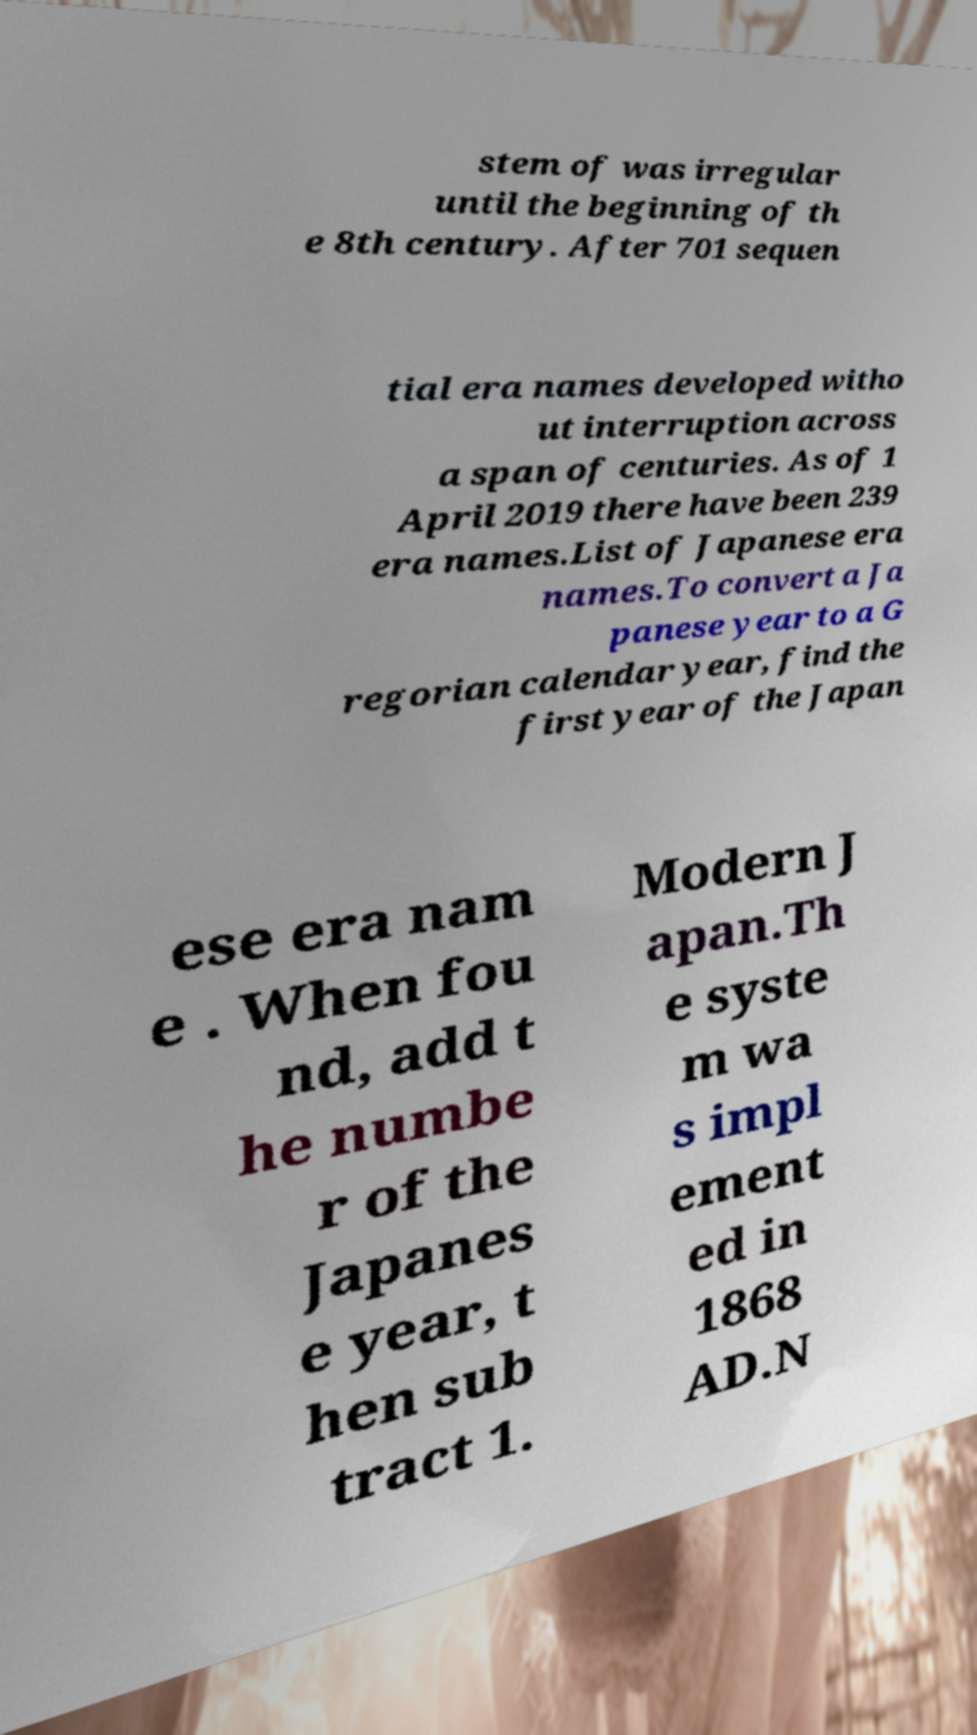I need the written content from this picture converted into text. Can you do that? stem of was irregular until the beginning of th e 8th century. After 701 sequen tial era names developed witho ut interruption across a span of centuries. As of 1 April 2019 there have been 239 era names.List of Japanese era names.To convert a Ja panese year to a G regorian calendar year, find the first year of the Japan ese era nam e . When fou nd, add t he numbe r of the Japanes e year, t hen sub tract 1. Modern J apan.Th e syste m wa s impl ement ed in 1868 AD.N 